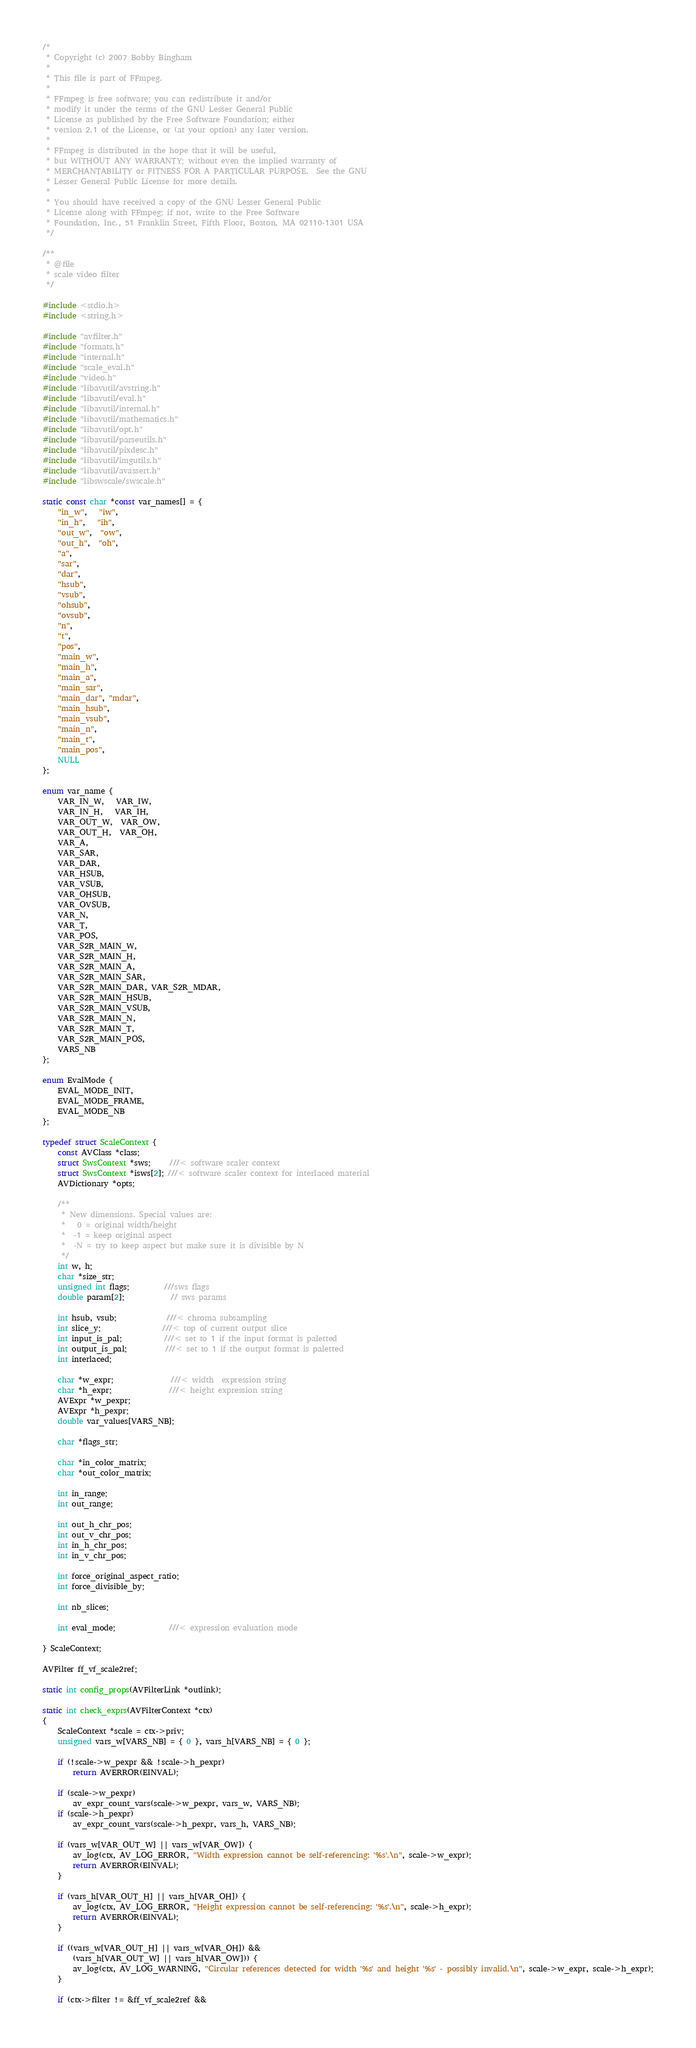<code> <loc_0><loc_0><loc_500><loc_500><_C_>/*
 * Copyright (c) 2007 Bobby Bingham
 *
 * This file is part of FFmpeg.
 *
 * FFmpeg is free software; you can redistribute it and/or
 * modify it under the terms of the GNU Lesser General Public
 * License as published by the Free Software Foundation; either
 * version 2.1 of the License, or (at your option) any later version.
 *
 * FFmpeg is distributed in the hope that it will be useful,
 * but WITHOUT ANY WARRANTY; without even the implied warranty of
 * MERCHANTABILITY or FITNESS FOR A PARTICULAR PURPOSE.  See the GNU
 * Lesser General Public License for more details.
 *
 * You should have received a copy of the GNU Lesser General Public
 * License along with FFmpeg; if not, write to the Free Software
 * Foundation, Inc., 51 Franklin Street, Fifth Floor, Boston, MA 02110-1301 USA
 */

/**
 * @file
 * scale video filter
 */

#include <stdio.h>
#include <string.h>

#include "avfilter.h"
#include "formats.h"
#include "internal.h"
#include "scale_eval.h"
#include "video.h"
#include "libavutil/avstring.h"
#include "libavutil/eval.h"
#include "libavutil/internal.h"
#include "libavutil/mathematics.h"
#include "libavutil/opt.h"
#include "libavutil/parseutils.h"
#include "libavutil/pixdesc.h"
#include "libavutil/imgutils.h"
#include "libavutil/avassert.h"
#include "libswscale/swscale.h"

static const char *const var_names[] = {
    "in_w",   "iw",
    "in_h",   "ih",
    "out_w",  "ow",
    "out_h",  "oh",
    "a",
    "sar",
    "dar",
    "hsub",
    "vsub",
    "ohsub",
    "ovsub",
    "n",
    "t",
    "pos",
    "main_w",
    "main_h",
    "main_a",
    "main_sar",
    "main_dar", "mdar",
    "main_hsub",
    "main_vsub",
    "main_n",
    "main_t",
    "main_pos",
    NULL
};

enum var_name {
    VAR_IN_W,   VAR_IW,
    VAR_IN_H,   VAR_IH,
    VAR_OUT_W,  VAR_OW,
    VAR_OUT_H,  VAR_OH,
    VAR_A,
    VAR_SAR,
    VAR_DAR,
    VAR_HSUB,
    VAR_VSUB,
    VAR_OHSUB,
    VAR_OVSUB,
    VAR_N,
    VAR_T,
    VAR_POS,
    VAR_S2R_MAIN_W,
    VAR_S2R_MAIN_H,
    VAR_S2R_MAIN_A,
    VAR_S2R_MAIN_SAR,
    VAR_S2R_MAIN_DAR, VAR_S2R_MDAR,
    VAR_S2R_MAIN_HSUB,
    VAR_S2R_MAIN_VSUB,
    VAR_S2R_MAIN_N,
    VAR_S2R_MAIN_T,
    VAR_S2R_MAIN_POS,
    VARS_NB
};

enum EvalMode {
    EVAL_MODE_INIT,
    EVAL_MODE_FRAME,
    EVAL_MODE_NB
};

typedef struct ScaleContext {
    const AVClass *class;
    struct SwsContext *sws;     ///< software scaler context
    struct SwsContext *isws[2]; ///< software scaler context for interlaced material
    AVDictionary *opts;

    /**
     * New dimensions. Special values are:
     *   0 = original width/height
     *  -1 = keep original aspect
     *  -N = try to keep aspect but make sure it is divisible by N
     */
    int w, h;
    char *size_str;
    unsigned int flags;         ///sws flags
    double param[2];            // sws params

    int hsub, vsub;             ///< chroma subsampling
    int slice_y;                ///< top of current output slice
    int input_is_pal;           ///< set to 1 if the input format is paletted
    int output_is_pal;          ///< set to 1 if the output format is paletted
    int interlaced;

    char *w_expr;               ///< width  expression string
    char *h_expr;               ///< height expression string
    AVExpr *w_pexpr;
    AVExpr *h_pexpr;
    double var_values[VARS_NB];

    char *flags_str;

    char *in_color_matrix;
    char *out_color_matrix;

    int in_range;
    int out_range;

    int out_h_chr_pos;
    int out_v_chr_pos;
    int in_h_chr_pos;
    int in_v_chr_pos;

    int force_original_aspect_ratio;
    int force_divisible_by;

    int nb_slices;

    int eval_mode;              ///< expression evaluation mode

} ScaleContext;

AVFilter ff_vf_scale2ref;

static int config_props(AVFilterLink *outlink);

static int check_exprs(AVFilterContext *ctx)
{
    ScaleContext *scale = ctx->priv;
    unsigned vars_w[VARS_NB] = { 0 }, vars_h[VARS_NB] = { 0 };

    if (!scale->w_pexpr && !scale->h_pexpr)
        return AVERROR(EINVAL);

    if (scale->w_pexpr)
        av_expr_count_vars(scale->w_pexpr, vars_w, VARS_NB);
    if (scale->h_pexpr)
        av_expr_count_vars(scale->h_pexpr, vars_h, VARS_NB);

    if (vars_w[VAR_OUT_W] || vars_w[VAR_OW]) {
        av_log(ctx, AV_LOG_ERROR, "Width expression cannot be self-referencing: '%s'.\n", scale->w_expr);
        return AVERROR(EINVAL);
    }

    if (vars_h[VAR_OUT_H] || vars_h[VAR_OH]) {
        av_log(ctx, AV_LOG_ERROR, "Height expression cannot be self-referencing: '%s'.\n", scale->h_expr);
        return AVERROR(EINVAL);
    }

    if ((vars_w[VAR_OUT_H] || vars_w[VAR_OH]) &&
        (vars_h[VAR_OUT_W] || vars_h[VAR_OW])) {
        av_log(ctx, AV_LOG_WARNING, "Circular references detected for width '%s' and height '%s' - possibly invalid.\n", scale->w_expr, scale->h_expr);
    }

    if (ctx->filter != &ff_vf_scale2ref &&</code> 